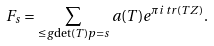<formula> <loc_0><loc_0><loc_500><loc_500>F _ { s } = \sum _ { \leq g { \det ( T ) } { p } = s } a ( T ) e ^ { \pi i \, t r ( T Z ) } .</formula> 